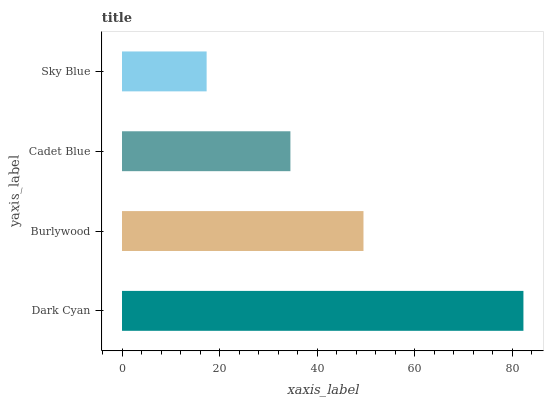Is Sky Blue the minimum?
Answer yes or no. Yes. Is Dark Cyan the maximum?
Answer yes or no. Yes. Is Burlywood the minimum?
Answer yes or no. No. Is Burlywood the maximum?
Answer yes or no. No. Is Dark Cyan greater than Burlywood?
Answer yes or no. Yes. Is Burlywood less than Dark Cyan?
Answer yes or no. Yes. Is Burlywood greater than Dark Cyan?
Answer yes or no. No. Is Dark Cyan less than Burlywood?
Answer yes or no. No. Is Burlywood the high median?
Answer yes or no. Yes. Is Cadet Blue the low median?
Answer yes or no. Yes. Is Sky Blue the high median?
Answer yes or no. No. Is Dark Cyan the low median?
Answer yes or no. No. 